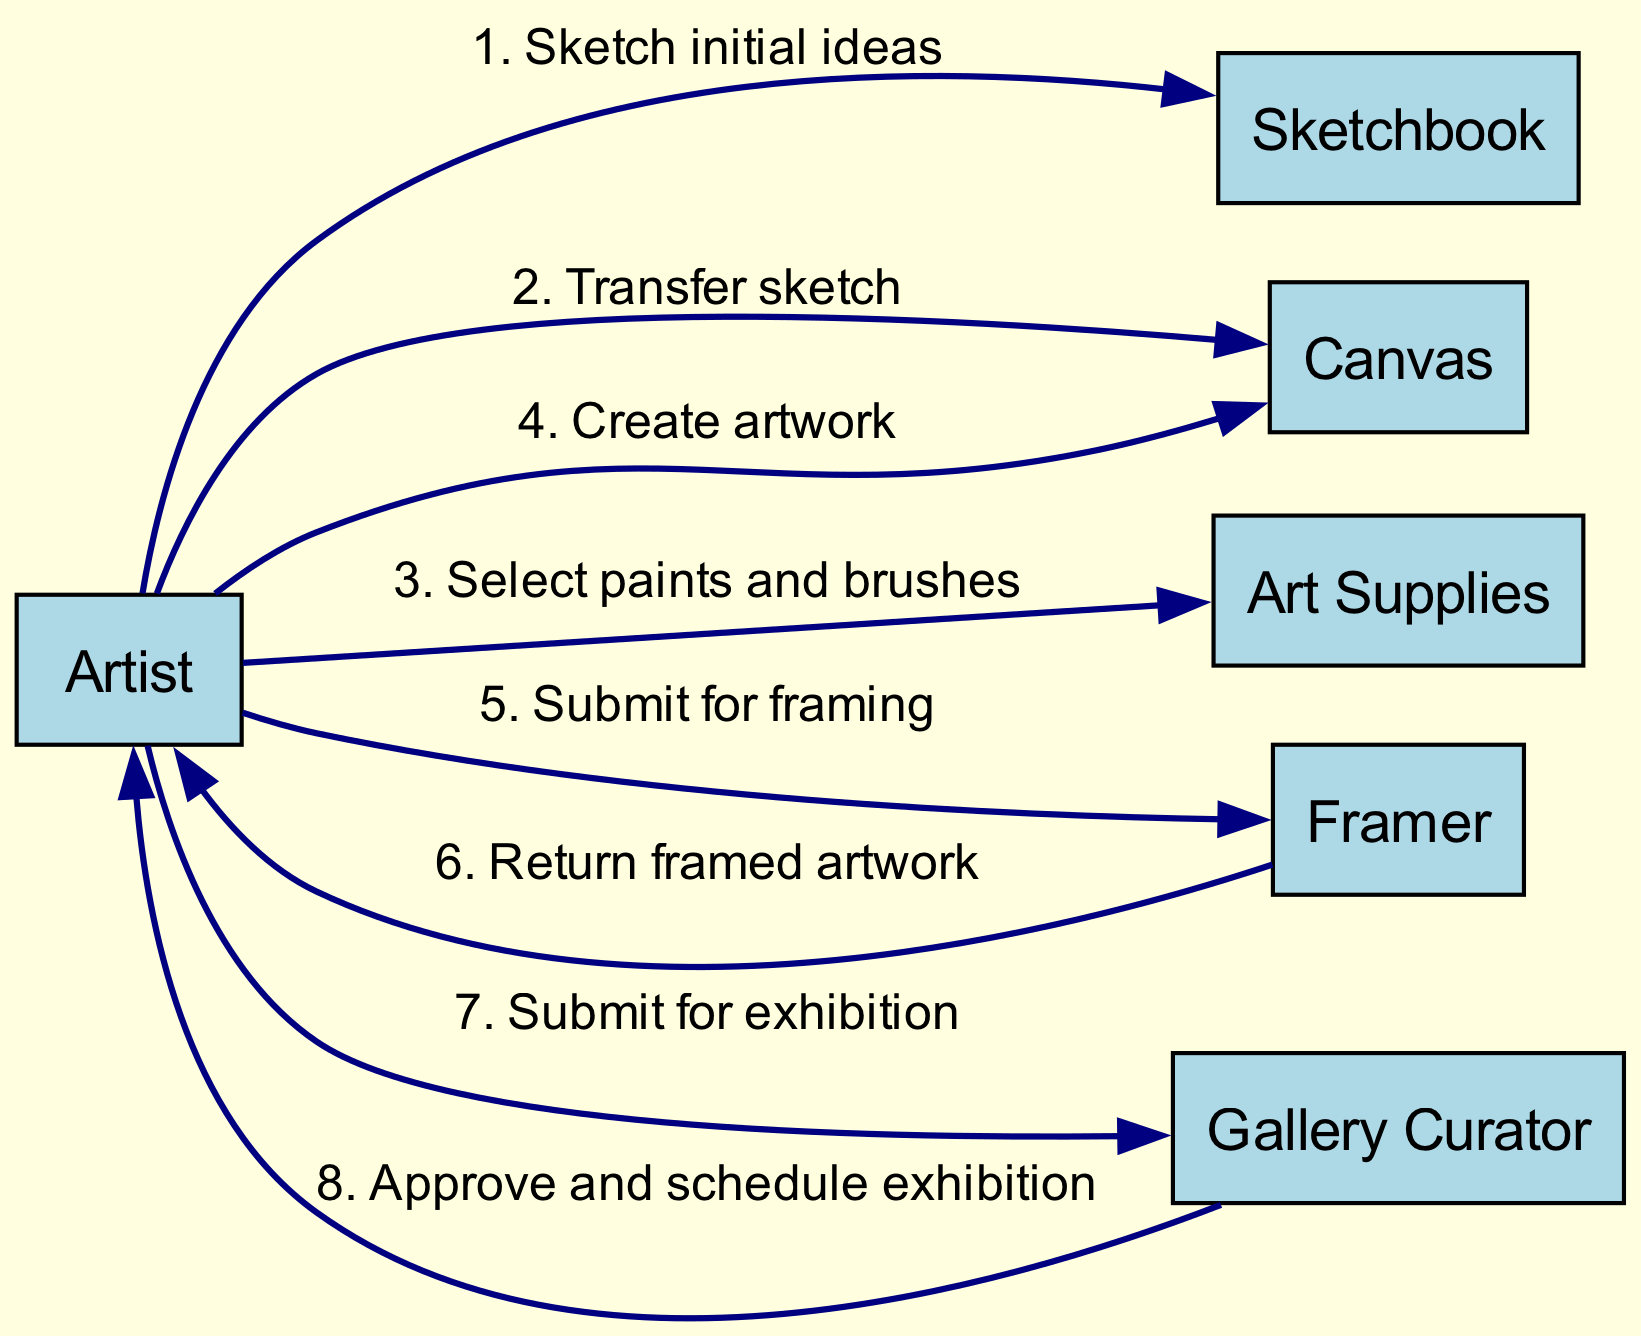What is the first action in the sequence? The first action in the sequence is when the Artist sketches initial ideas in the Sketchbook. This is the first entry in the sequence list.
Answer: Sketch initial ideas Who does the Artist submit the artwork to after creating it? After creating the artwork on the Canvas, the Artist submits it to the Framer. This is indicated in the sequence where the Artist acts upon the Canvas first and then interacts with the Framer next.
Answer: Framer How many actors are involved in the diagram? There are six actors in the diagram: Artist, Sketchbook, Canvas, Art Supplies, Framer, and Gallery Curator. Since the initial data lists six unique roles, we can confirm this count.
Answer: 6 What is the last interaction in the sequence? The last interaction is between the Gallery Curator and the Artist where the Gallery Curator approves and schedules the exhibition. This is the final step detailed in the sequence flow.
Answer: Approve and schedule exhibition Which actor is responsible for returning the framed artwork? The Framer is responsible for returning the framed artwork to the Artist. This is shown in the sequence where the Framer communicates back to the Artist after framing.
Answer: Framer What action follows selecting paints and brushes? The action that follows selecting paints and brushes is creating artwork on the Canvas. This can be traced by observing the flow from the Art Supplies to the Canvas in the sequence steps.
Answer: Create artwork What action comes before submitting for exhibition? The action that comes before submitting for exhibition is submitting the artwork for framing. This precedes the Artist's interaction with the Gallery Curator.
Answer: Submit for framing Which two actors have a direct interaction without the Artist? The Framer and the Artist have a direct interaction since the Framer returns the framed artwork to the Artist. This is the only instance where two actors interact without the Artist being involved.
Answer: Framer and Artist 